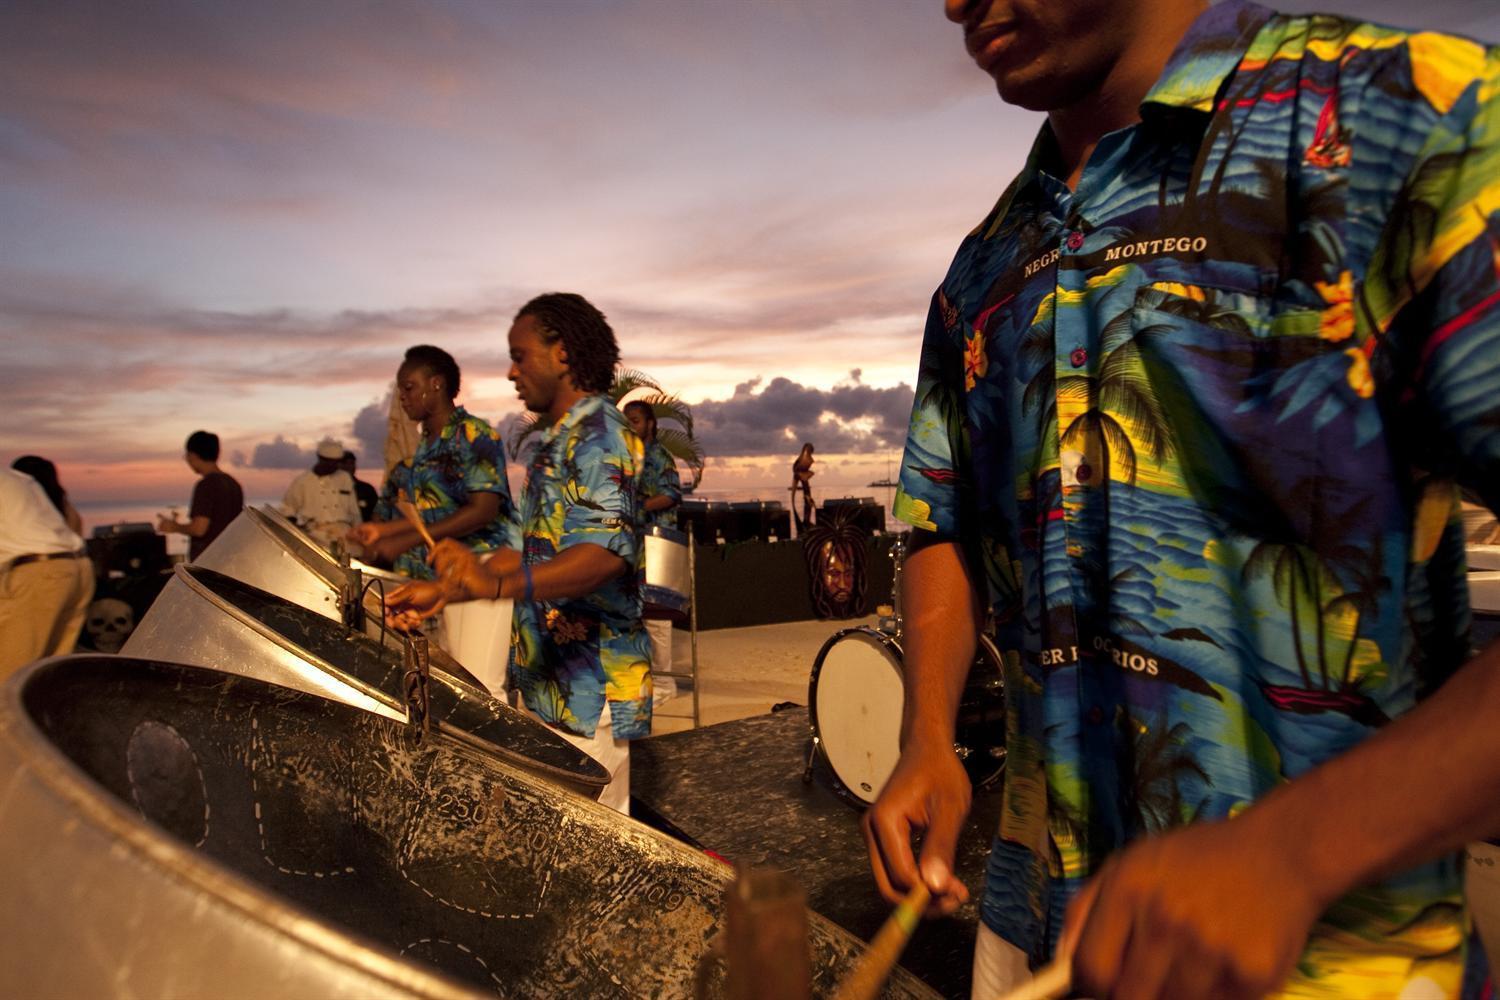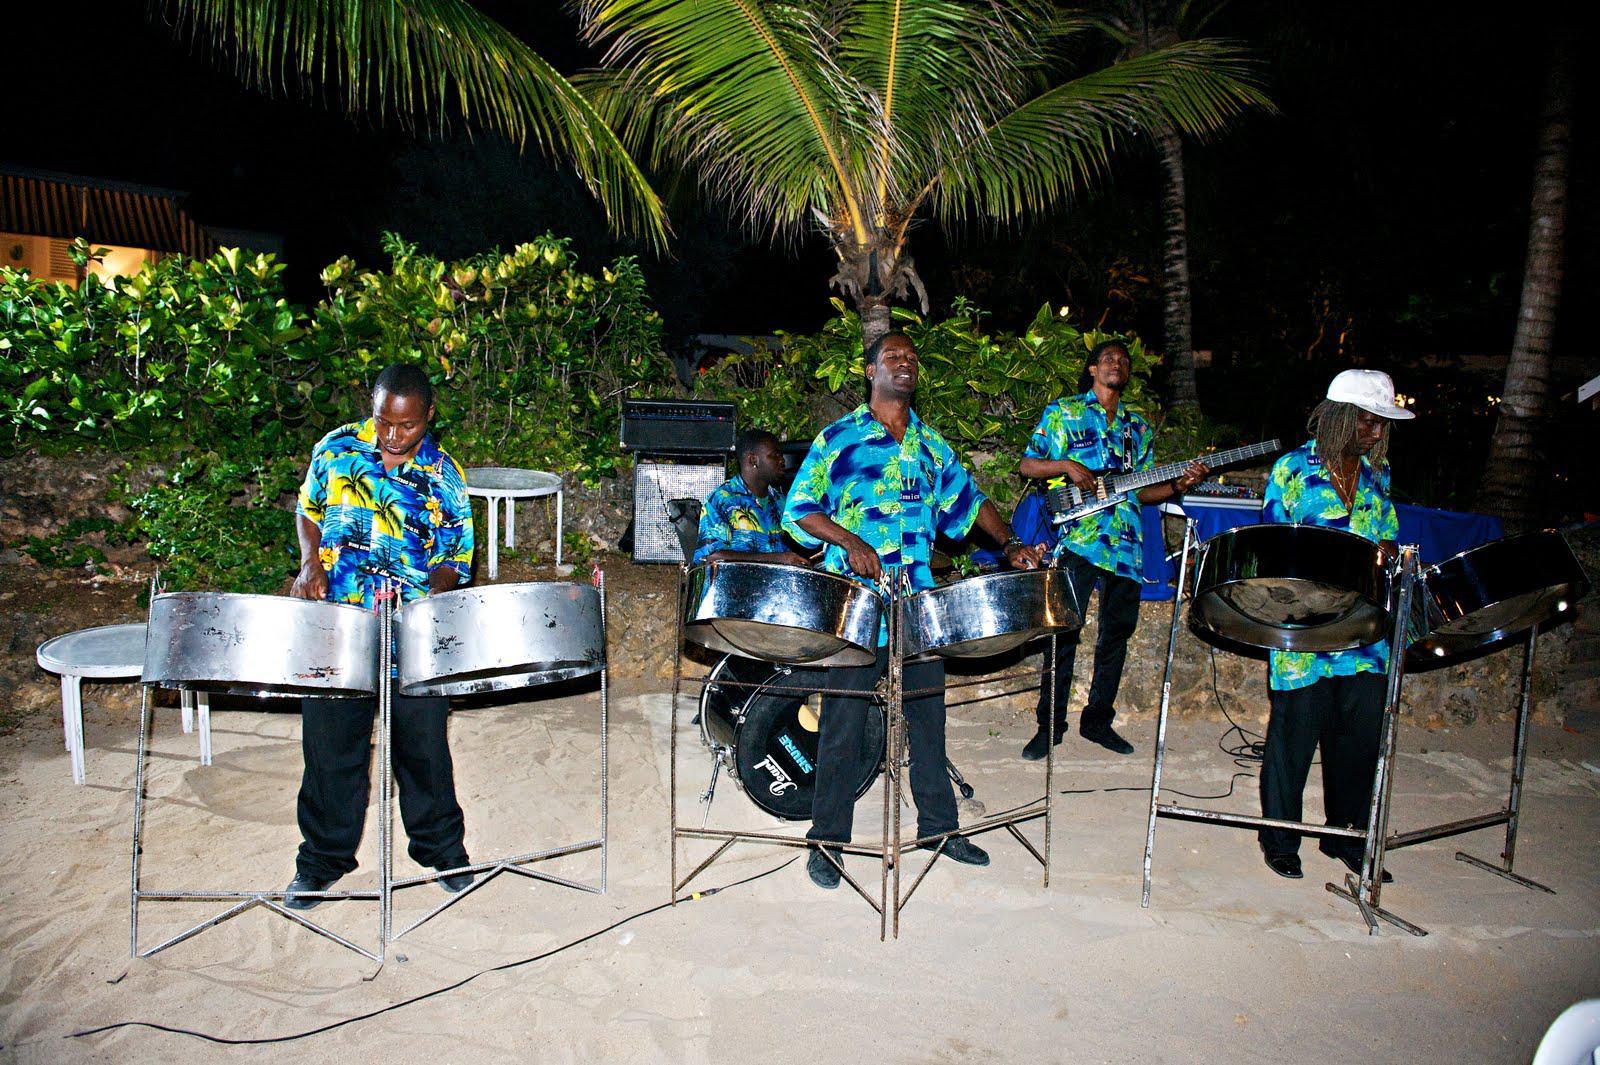The first image is the image on the left, the second image is the image on the right. Given the left and right images, does the statement "In one of the images, three people in straw hats are playing instruments." hold true? Answer yes or no. No. 